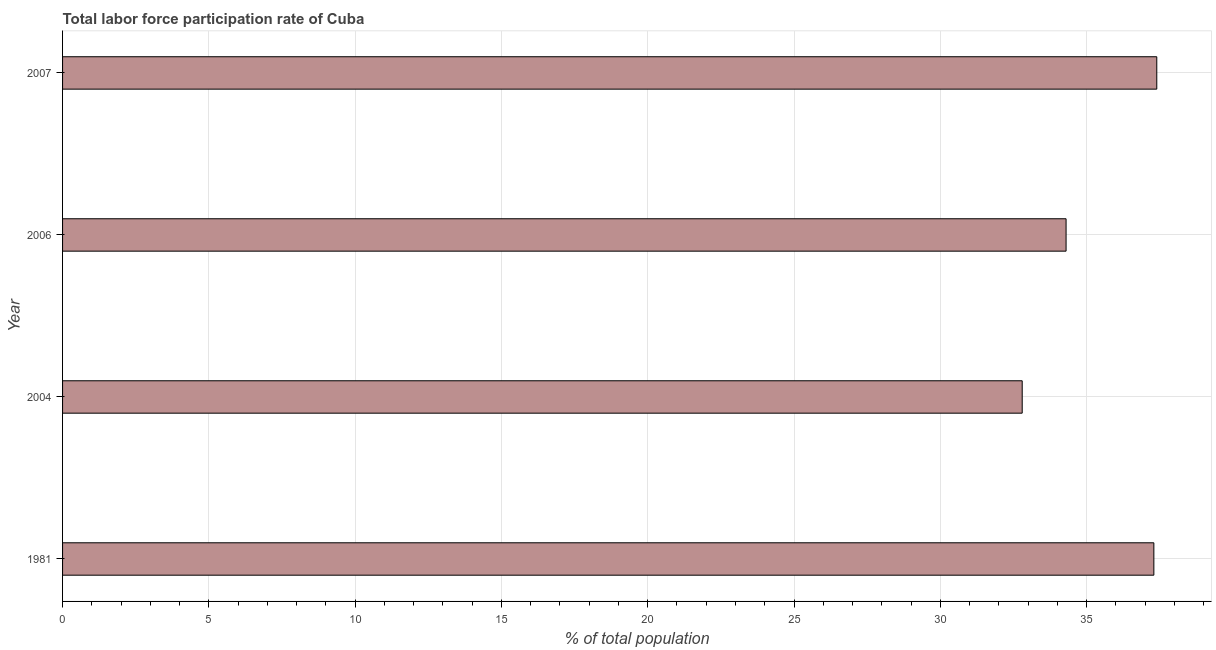Does the graph contain any zero values?
Offer a very short reply. No. What is the title of the graph?
Keep it short and to the point. Total labor force participation rate of Cuba. What is the label or title of the X-axis?
Make the answer very short. % of total population. What is the label or title of the Y-axis?
Offer a very short reply. Year. What is the total labor force participation rate in 2007?
Offer a very short reply. 37.4. Across all years, what is the maximum total labor force participation rate?
Your answer should be compact. 37.4. Across all years, what is the minimum total labor force participation rate?
Offer a terse response. 32.8. What is the sum of the total labor force participation rate?
Your answer should be compact. 141.8. What is the average total labor force participation rate per year?
Offer a very short reply. 35.45. What is the median total labor force participation rate?
Offer a terse response. 35.8. What is the ratio of the total labor force participation rate in 2006 to that in 2007?
Keep it short and to the point. 0.92. Is the total labor force participation rate in 1981 less than that in 2004?
Ensure brevity in your answer.  No. Is the difference between the total labor force participation rate in 2004 and 2006 greater than the difference between any two years?
Your answer should be compact. No. What is the difference between the highest and the second highest total labor force participation rate?
Ensure brevity in your answer.  0.1. Is the sum of the total labor force participation rate in 1981 and 2004 greater than the maximum total labor force participation rate across all years?
Provide a short and direct response. Yes. What is the difference between the highest and the lowest total labor force participation rate?
Keep it short and to the point. 4.6. In how many years, is the total labor force participation rate greater than the average total labor force participation rate taken over all years?
Provide a short and direct response. 2. Are all the bars in the graph horizontal?
Your response must be concise. Yes. What is the difference between two consecutive major ticks on the X-axis?
Provide a succinct answer. 5. What is the % of total population of 1981?
Give a very brief answer. 37.3. What is the % of total population in 2004?
Give a very brief answer. 32.8. What is the % of total population of 2006?
Provide a short and direct response. 34.3. What is the % of total population of 2007?
Ensure brevity in your answer.  37.4. What is the difference between the % of total population in 2004 and 2006?
Your response must be concise. -1.5. What is the difference between the % of total population in 2004 and 2007?
Make the answer very short. -4.6. What is the ratio of the % of total population in 1981 to that in 2004?
Your answer should be compact. 1.14. What is the ratio of the % of total population in 1981 to that in 2006?
Make the answer very short. 1.09. What is the ratio of the % of total population in 2004 to that in 2006?
Make the answer very short. 0.96. What is the ratio of the % of total population in 2004 to that in 2007?
Keep it short and to the point. 0.88. What is the ratio of the % of total population in 2006 to that in 2007?
Provide a succinct answer. 0.92. 